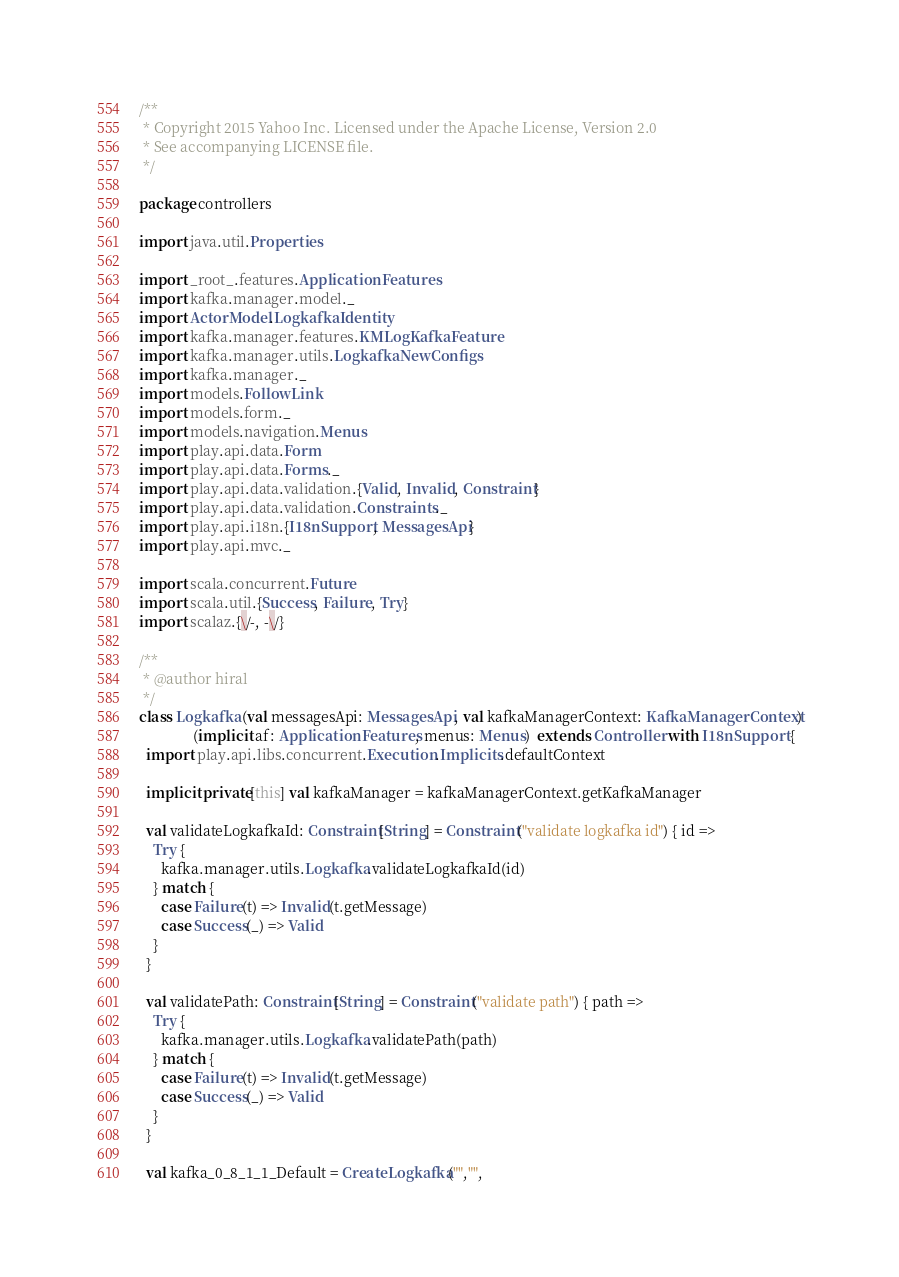<code> <loc_0><loc_0><loc_500><loc_500><_Scala_>/**
 * Copyright 2015 Yahoo Inc. Licensed under the Apache License, Version 2.0
 * See accompanying LICENSE file.
 */

package controllers

import java.util.Properties

import _root_.features.ApplicationFeatures
import kafka.manager.model._
import ActorModel.LogkafkaIdentity
import kafka.manager.features.KMLogKafkaFeature
import kafka.manager.utils.LogkafkaNewConfigs
import kafka.manager._
import models.FollowLink
import models.form._
import models.navigation.Menus
import play.api.data.Form
import play.api.data.Forms._
import play.api.data.validation.{Valid, Invalid, Constraint}
import play.api.data.validation.Constraints._
import play.api.i18n.{I18nSupport, MessagesApi}
import play.api.mvc._

import scala.concurrent.Future
import scala.util.{Success, Failure, Try}
import scalaz.{\/-, -\/}

/**
 * @author hiral
 */
class Logkafka (val messagesApi: MessagesApi, val kafkaManagerContext: KafkaManagerContext)
               (implicit af: ApplicationFeatures, menus: Menus)  extends Controller with I18nSupport {
  import play.api.libs.concurrent.Execution.Implicits.defaultContext

  implicit private[this] val kafkaManager = kafkaManagerContext.getKafkaManager

  val validateLogkafkaId: Constraint[String] = Constraint("validate logkafka id") { id =>
    Try {
      kafka.manager.utils.Logkafka.validateLogkafkaId(id)
    } match {
      case Failure(t) => Invalid(t.getMessage)
      case Success(_) => Valid
    }
  }

  val validatePath: Constraint[String] = Constraint("validate path") { path =>
    Try {
      kafka.manager.utils.Logkafka.validatePath(path)
    } match {
      case Failure(t) => Invalid(t.getMessage)
      case Success(_) => Valid
    }
  }
  
  val kafka_0_8_1_1_Default = CreateLogkafka("","",</code> 